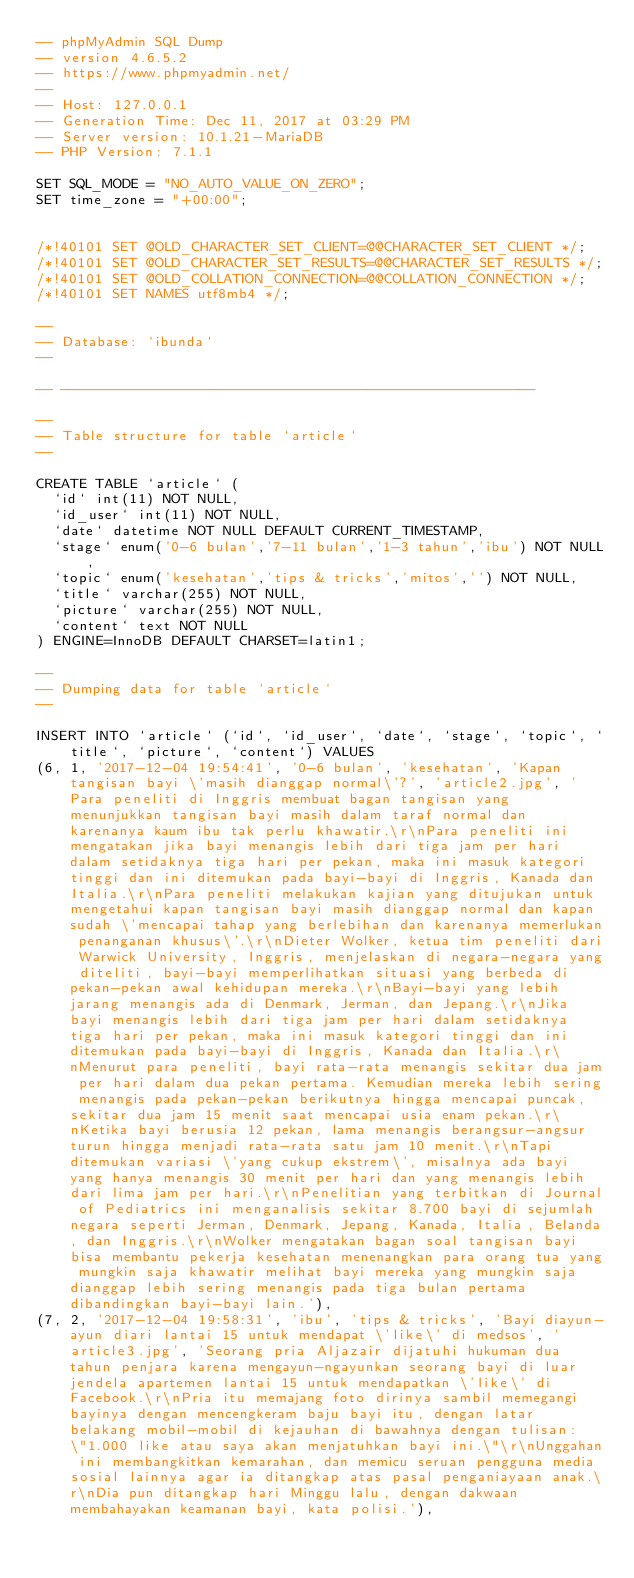<code> <loc_0><loc_0><loc_500><loc_500><_SQL_>-- phpMyAdmin SQL Dump
-- version 4.6.5.2
-- https://www.phpmyadmin.net/
--
-- Host: 127.0.0.1
-- Generation Time: Dec 11, 2017 at 03:29 PM
-- Server version: 10.1.21-MariaDB
-- PHP Version: 7.1.1

SET SQL_MODE = "NO_AUTO_VALUE_ON_ZERO";
SET time_zone = "+00:00";


/*!40101 SET @OLD_CHARACTER_SET_CLIENT=@@CHARACTER_SET_CLIENT */;
/*!40101 SET @OLD_CHARACTER_SET_RESULTS=@@CHARACTER_SET_RESULTS */;
/*!40101 SET @OLD_COLLATION_CONNECTION=@@COLLATION_CONNECTION */;
/*!40101 SET NAMES utf8mb4 */;

--
-- Database: `ibunda`
--

-- --------------------------------------------------------

--
-- Table structure for table `article`
--

CREATE TABLE `article` (
  `id` int(11) NOT NULL,
  `id_user` int(11) NOT NULL,
  `date` datetime NOT NULL DEFAULT CURRENT_TIMESTAMP,
  `stage` enum('0-6 bulan','7-11 bulan','1-3 tahun','ibu') NOT NULL,
  `topic` enum('kesehatan','tips & tricks','mitos','') NOT NULL,
  `title` varchar(255) NOT NULL,
  `picture` varchar(255) NOT NULL,
  `content` text NOT NULL
) ENGINE=InnoDB DEFAULT CHARSET=latin1;

--
-- Dumping data for table `article`
--

INSERT INTO `article` (`id`, `id_user`, `date`, `stage`, `topic`, `title`, `picture`, `content`) VALUES
(6, 1, '2017-12-04 19:54:41', '0-6 bulan', 'kesehatan', 'Kapan tangisan bayi \'masih dianggap normal\'?', 'article2.jpg', 'Para peneliti di Inggris membuat bagan tangisan yang menunjukkan tangisan bayi masih dalam taraf normal dan karenanya kaum ibu tak perlu khawatir.\r\nPara peneliti ini mengatakan jika bayi menangis lebih dari tiga jam per hari dalam setidaknya tiga hari per pekan, maka ini masuk kategori tinggi dan ini ditemukan pada bayi-bayi di Inggris, Kanada dan Italia.\r\nPara peneliti melakukan kajian yang ditujukan untuk mengetahui kapan tangisan bayi masih dianggap normal dan kapan sudah \'mencapai tahap yang berlebihan dan karenanya memerlukan penanganan khusus\'.\r\nDieter Wolker, ketua tim peneliti dari Warwick University, Inggris, menjelaskan di negara-negara yang diteliti, bayi-bayi memperlihatkan situasi yang berbeda di pekan-pekan awal kehidupan mereka.\r\nBayi-bayi yang lebih jarang menangis ada di Denmark, Jerman, dan Jepang.\r\nJika bayi menangis lebih dari tiga jam per hari dalam setidaknya tiga hari per pekan, maka ini masuk kategori tinggi dan ini ditemukan pada bayi-bayi di Inggris, Kanada dan Italia.\r\nMenurut para peneliti, bayi rata-rata menangis sekitar dua jam per hari dalam dua pekan pertama. Kemudian mereka lebih sering menangis pada pekan-pekan berikutnya hingga mencapai puncak, sekitar dua jam 15 menit saat mencapai usia enam pekan.\r\nKetika bayi berusia 12 pekan, lama menangis berangsur-angsur turun hingga menjadi rata-rata satu jam 10 menit.\r\nTapi ditemukan variasi \'yang cukup ekstrem\', misalnya ada bayi yang hanya menangis 30 menit per hari dan yang menangis lebih dari lima jam per hari.\r\nPenelitian yang terbitkan di Journal of Pediatrics ini menganalisis sekitar 8.700 bayi di sejumlah negara seperti Jerman, Denmark, Jepang, Kanada, Italia, Belanda, dan Inggris.\r\nWolker mengatakan bagan soal tangisan bayi bisa membantu pekerja kesehatan menenangkan para orang tua yang mungkin saja khawatir melihat bayi mereka yang mungkin saja dianggap lebih sering menangis pada tiga bulan pertama dibandingkan bayi-bayi lain.'),
(7, 2, '2017-12-04 19:58:31', 'ibu', 'tips & tricks', 'Bayi diayun-ayun diari lantai 15 untuk mendapat \'like\' di medsos', 'article3.jpg', 'Seorang pria Aljazair dijatuhi hukuman dua tahun penjara karena mengayun-ngayunkan seorang bayi di luar jendela apartemen lantai 15 untuk mendapatkan \'like\' di Facebook.\r\nPria itu memajang foto dirinya sambil memegangi bayinya dengan mencengkeram baju bayi itu, dengan latar belakang mobil-mobil di kejauhan di bawahnya dengan tulisan: \"1.000 like atau saya akan menjatuhkan bayi ini.\"\r\nUnggahan ini membangkitkan kemarahan, dan memicu seruan pengguna media sosial lainnya agar ia ditangkap atas pasal penganiayaan anak.\r\nDia pun ditangkap hari Minggu lalu, dengan dakwaan membahayakan keamanan bayi, kata polisi.'),</code> 